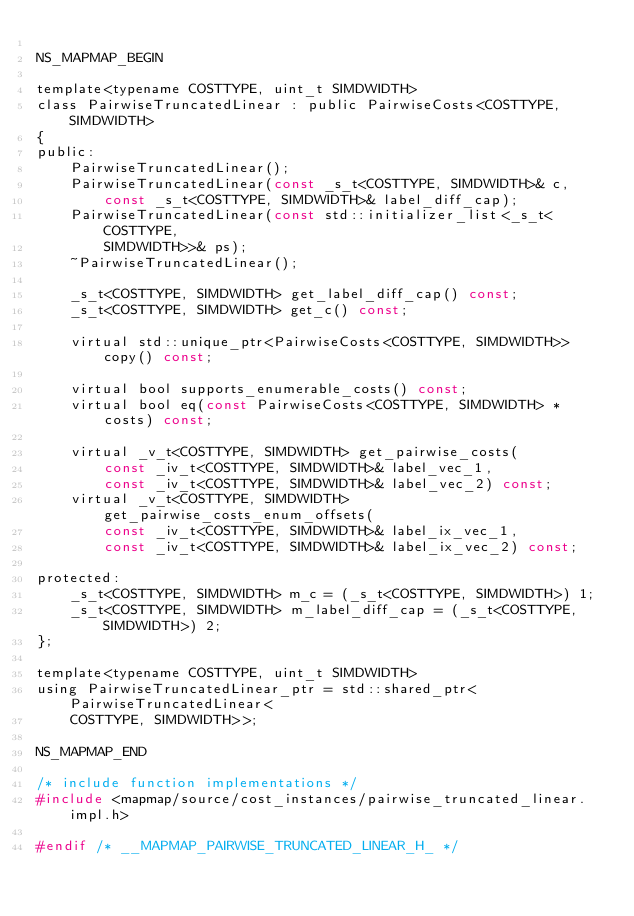<code> <loc_0><loc_0><loc_500><loc_500><_C_>
NS_MAPMAP_BEGIN

template<typename COSTTYPE, uint_t SIMDWIDTH>
class PairwiseTruncatedLinear : public PairwiseCosts<COSTTYPE, SIMDWIDTH>
{
public:
    PairwiseTruncatedLinear();
    PairwiseTruncatedLinear(const _s_t<COSTTYPE, SIMDWIDTH>& c,
        const _s_t<COSTTYPE, SIMDWIDTH>& label_diff_cap);
    PairwiseTruncatedLinear(const std::initializer_list<_s_t<COSTTYPE,
        SIMDWIDTH>>& ps);
    ~PairwiseTruncatedLinear();

    _s_t<COSTTYPE, SIMDWIDTH> get_label_diff_cap() const;
    _s_t<COSTTYPE, SIMDWIDTH> get_c() const;

    virtual std::unique_ptr<PairwiseCosts<COSTTYPE, SIMDWIDTH>> copy() const;

    virtual bool supports_enumerable_costs() const;
    virtual bool eq(const PairwiseCosts<COSTTYPE, SIMDWIDTH> * costs) const;

    virtual _v_t<COSTTYPE, SIMDWIDTH> get_pairwise_costs(
        const _iv_t<COSTTYPE, SIMDWIDTH>& label_vec_1,
        const _iv_t<COSTTYPE, SIMDWIDTH>& label_vec_2) const;
    virtual _v_t<COSTTYPE, SIMDWIDTH> get_pairwise_costs_enum_offsets(
        const _iv_t<COSTTYPE, SIMDWIDTH>& label_ix_vec_1,
        const _iv_t<COSTTYPE, SIMDWIDTH>& label_ix_vec_2) const;

protected:
    _s_t<COSTTYPE, SIMDWIDTH> m_c = (_s_t<COSTTYPE, SIMDWIDTH>) 1;
    _s_t<COSTTYPE, SIMDWIDTH> m_label_diff_cap = (_s_t<COSTTYPE, SIMDWIDTH>) 2;
};

template<typename COSTTYPE, uint_t SIMDWIDTH>
using PairwiseTruncatedLinear_ptr = std::shared_ptr<PairwiseTruncatedLinear<
    COSTTYPE, SIMDWIDTH>>;

NS_MAPMAP_END

/* include function implementations */
#include <mapmap/source/cost_instances/pairwise_truncated_linear.impl.h>

#endif /* __MAPMAP_PAIRWISE_TRUNCATED_LINEAR_H_ */
</code> 